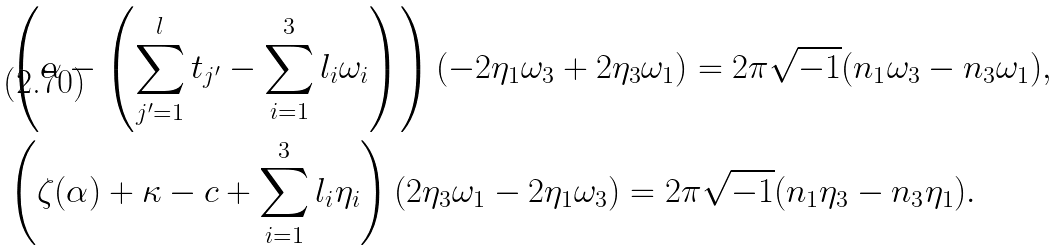<formula> <loc_0><loc_0><loc_500><loc_500>& \left ( \alpha - \left ( \sum _ { j ^ { \prime } = 1 } ^ { l } t _ { j ^ { \prime } } - \sum _ { i = 1 } ^ { 3 } l _ { i } \omega _ { i } \right ) \right ) ( - 2 \eta _ { 1 } \omega _ { 3 } + 2 \eta _ { 3 } \omega _ { 1 } ) = 2 \pi \sqrt { - 1 } ( n _ { 1 } \omega _ { 3 } - n _ { 3 } \omega _ { 1 } ) , \\ & \left ( \zeta ( \alpha ) + \kappa - c + \sum _ { i = 1 } ^ { 3 } l _ { i } \eta _ { i } \right ) ( 2 \eta _ { 3 } \omega _ { 1 } - 2 \eta _ { 1 } \omega _ { 3 } ) = 2 \pi \sqrt { - 1 } ( n _ { 1 } \eta _ { 3 } - n _ { 3 } \eta _ { 1 } ) .</formula> 